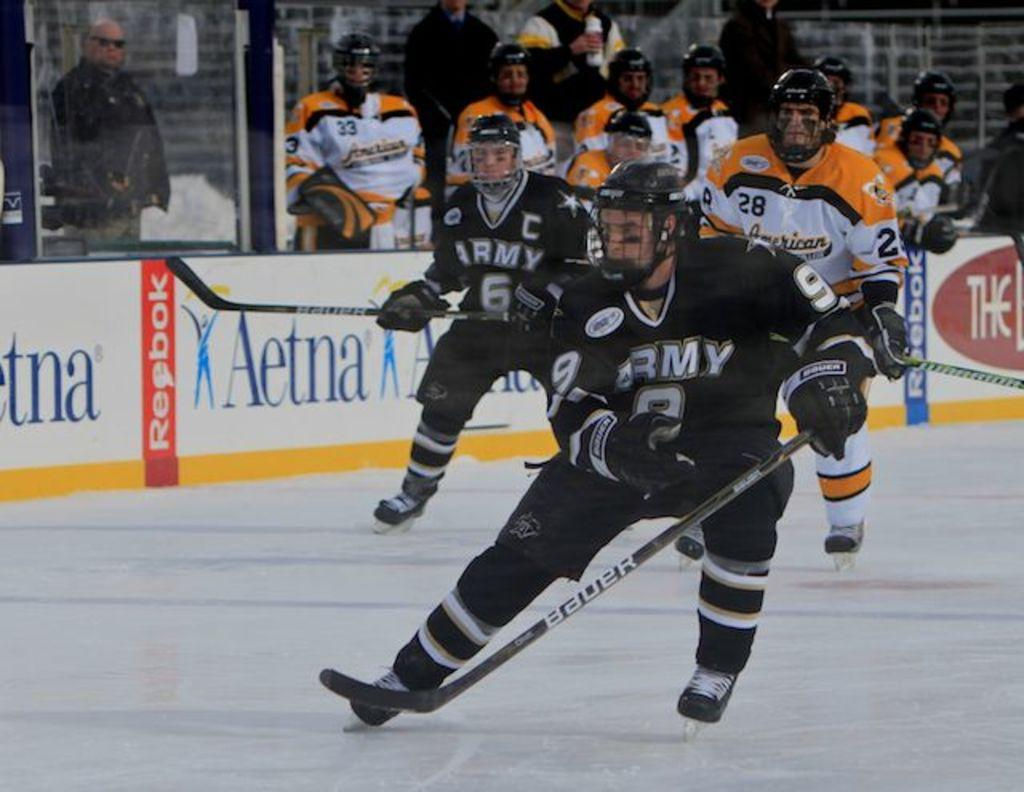<image>
Provide a brief description of the given image. Hockey players in black uniforms with Army on the front in white. 